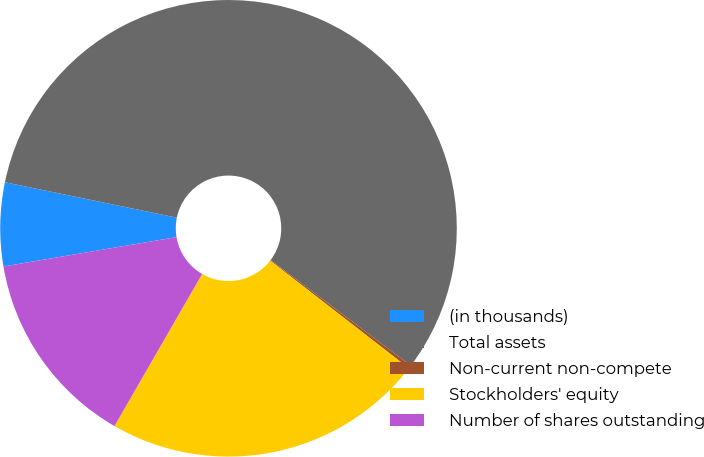Convert chart to OTSL. <chart><loc_0><loc_0><loc_500><loc_500><pie_chart><fcel>(in thousands)<fcel>Total assets<fcel>Non-current non-compete<fcel>Stockholders' equity<fcel>Number of shares outstanding<nl><fcel>5.91%<fcel>57.04%<fcel>0.23%<fcel>22.82%<fcel>14.0%<nl></chart> 